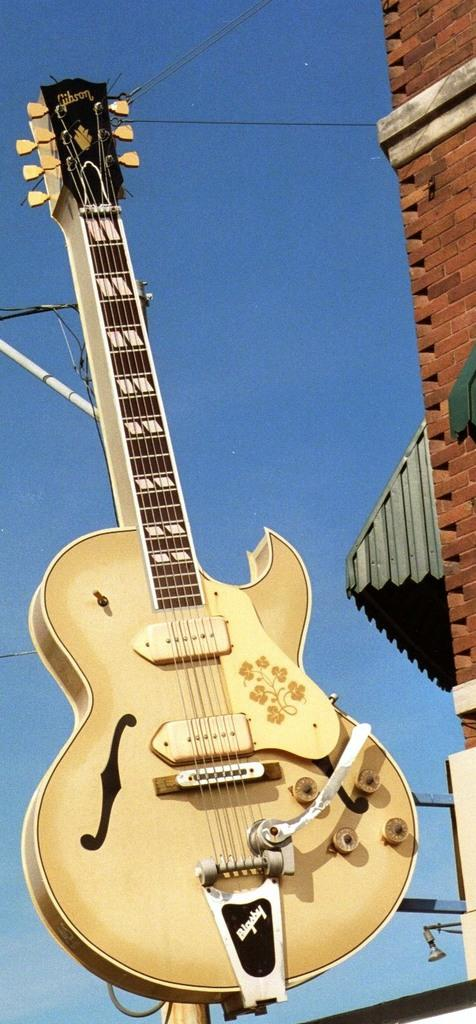What is the main object in the center of the image? There is a guitar in the center of the image. What can be seen in the background of the image? There is a building and a pole with wires in the background of the image. How many birds are sitting on the guitar in the image? There are no birds present in the image; it only features a guitar and a background with a building and a pole with wires. 